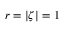Convert formula to latex. <formula><loc_0><loc_0><loc_500><loc_500>r = | \zeta | = 1</formula> 